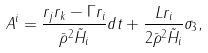Convert formula to latex. <formula><loc_0><loc_0><loc_500><loc_500>A ^ { i } = \frac { r _ { j } r _ { k } - \Gamma r _ { i } } { \bar { \rho } ^ { 2 } \tilde { H } _ { i } } d t + \frac { L r _ { i } } { 2 \bar { \rho } ^ { 2 } \tilde { H } _ { i } } \sigma _ { 3 } ,</formula> 